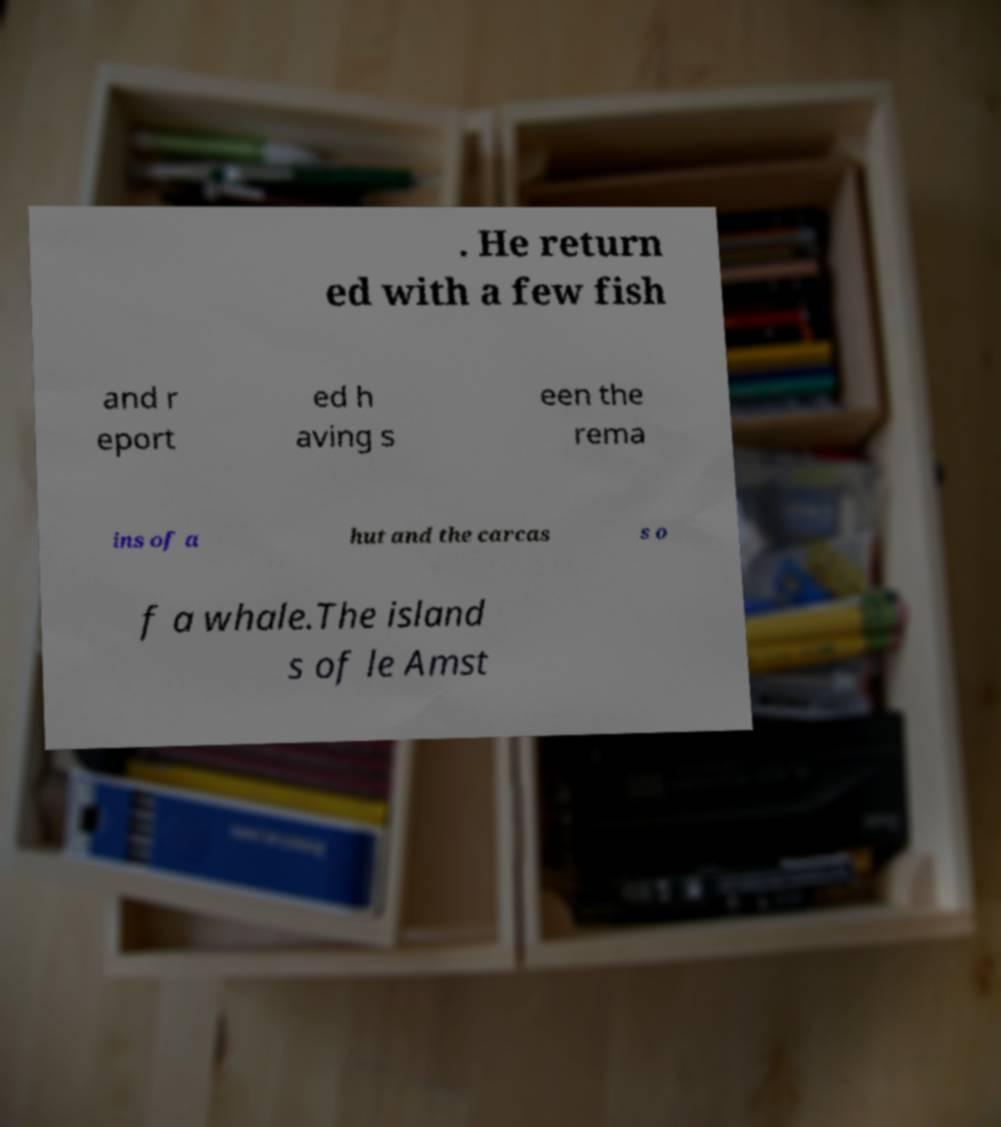Please identify and transcribe the text found in this image. . He return ed with a few fish and r eport ed h aving s een the rema ins of a hut and the carcas s o f a whale.The island s of le Amst 